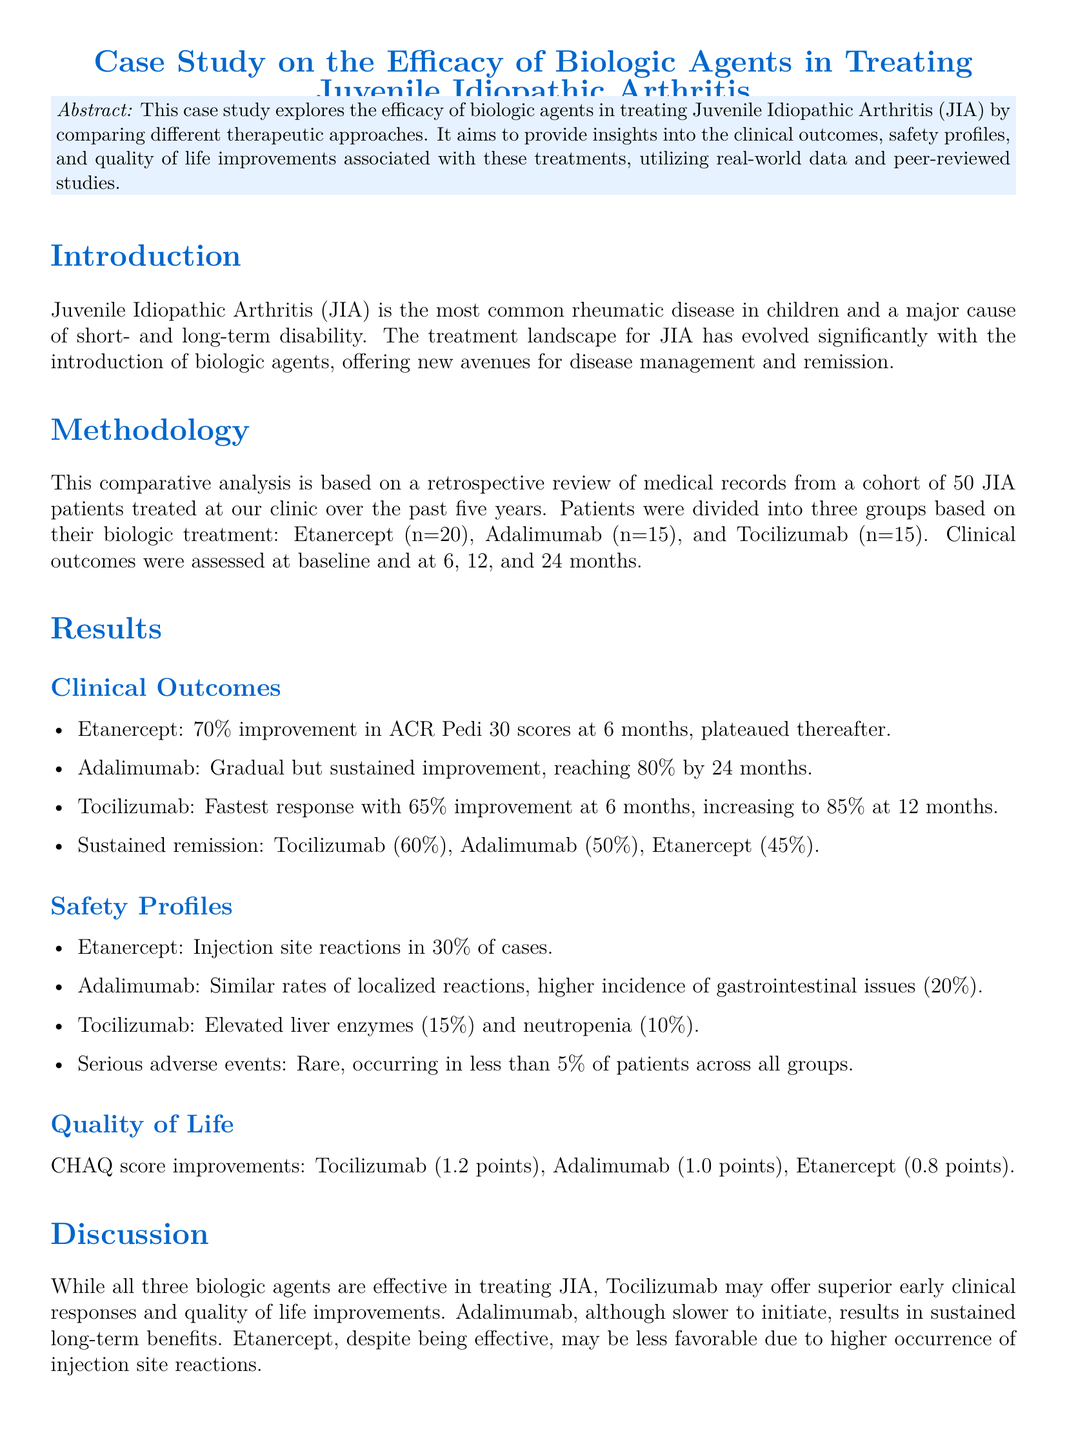What is the most common rheumatic disease in children? The document states that Juvenile Idiopathic Arthritis (JIA) is the most common rheumatic disease in children.
Answer: Juvenile Idiopathic Arthritis How many patients were treated with Adalimumab? The document specifies that there were 15 patients treated with Adalimumab in the study.
Answer: 15 What percentage of improvement did Tocilizumab show at 12 months? Tocilizumab showed an 85% improvement at 12 months, as reported in the results section.
Answer: 85% What adverse reaction was notably observed with Tocilizumab? The document mentions elevated liver enzymes as a notable adverse reaction observed with Tocilizumab.
Answer: Elevated liver enzymes Which biologic agent had the highest percentage of sustained remission? The sustained remission rates show that Tocilizumab had the highest rate at 60%.
Answer: Tocilizumab What was the CHAQ score improvement for Adalimumab? The CHAQ score improvement for Adalimumab was 1.0 points according to the results section.
Answer: 1.0 points What is the primary focus of this case study? The primary focus is to explore the efficacy of biologic agents in treating Juvenile Idiopathic Arthritis by comparing different therapeutic approaches.
Answer: Efficacy of biologic agents What type of analysis was performed in this study? A comparative analysis was conducted based on a retrospective review of medical records.
Answer: Comparative analysis 